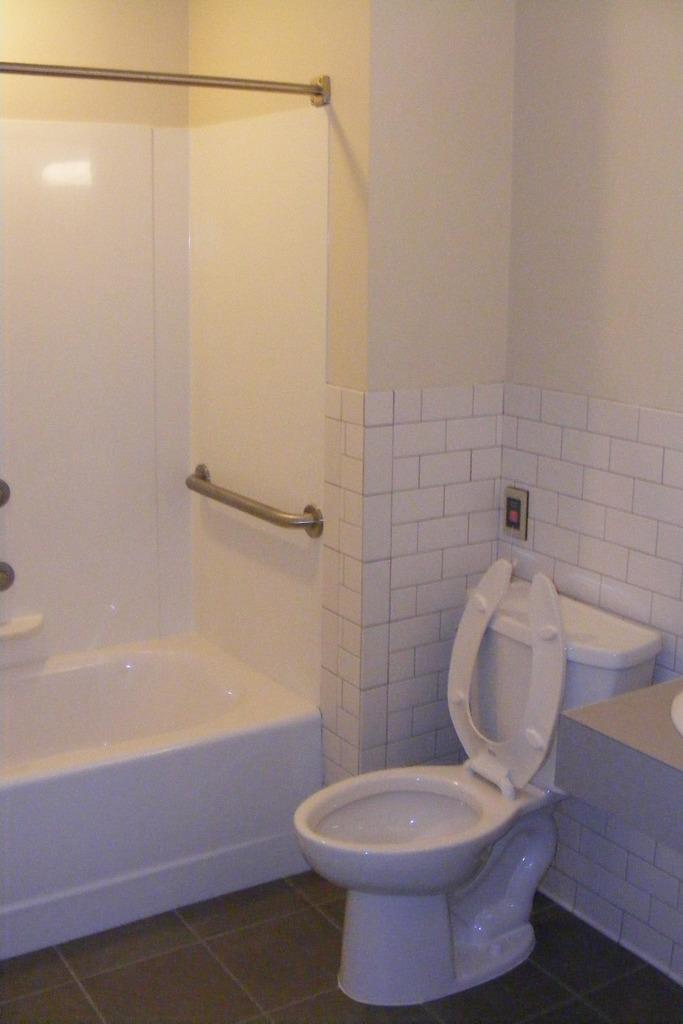What type of room is depicted in the image? The image is of a restroom. What type of fixtures are present in the restroom? There are pole stands, a bath tub, a western toilet, and a flush tank in the restroom. What type of storage is available in the restroom? There is a cupboard in the restroom. What is the flooring material in the restroom? The walls in the restroom have tiles, and the floor is visible. What type of fear can be seen on the faces of the pan in the image? There are no pans present in the image, and therefore no faces or fear can be observed. 